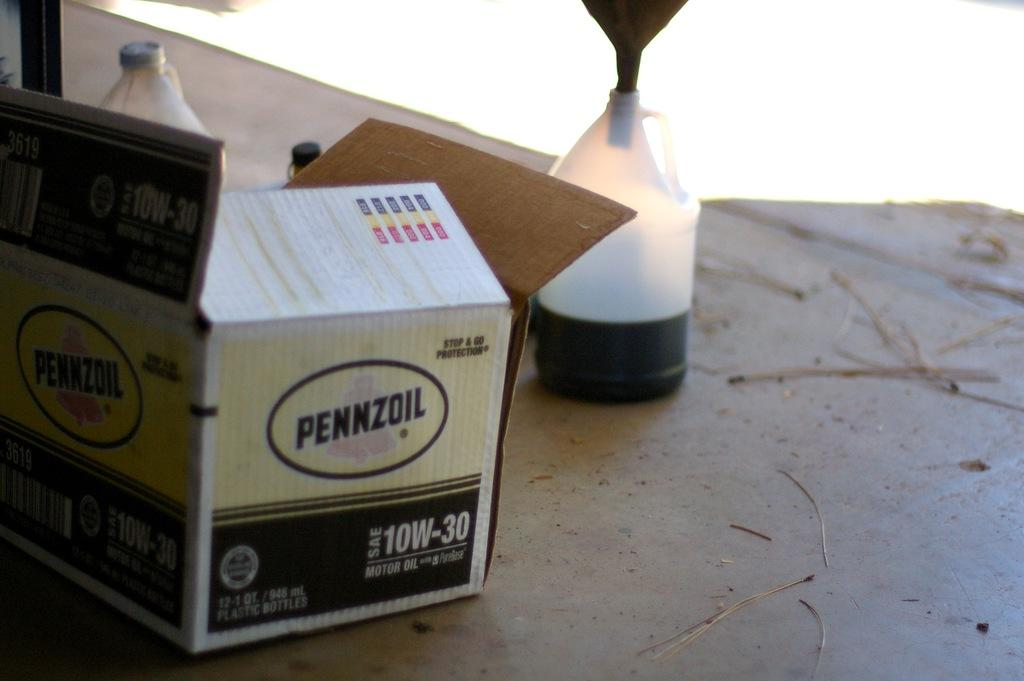<image>
Render a clear and concise summary of the photo. a box on the ground that is labeled 'pennzoil' on the side of it 